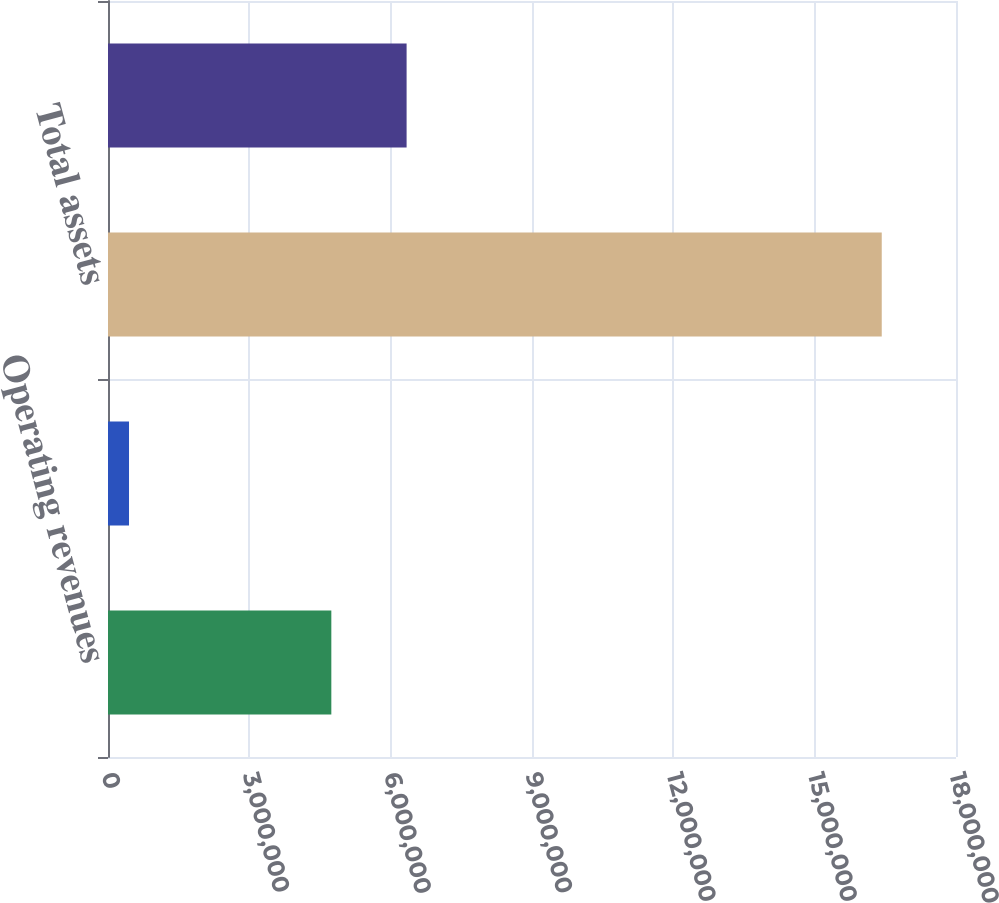<chart> <loc_0><loc_0><loc_500><loc_500><bar_chart><fcel>Operating revenues<fcel>Net income<fcel>Total assets<fcel>Long-term obligations (a)<nl><fcel>4.7405e+06<fcel>446022<fcel>1.64238e+07<fcel>6.33828e+06<nl></chart> 